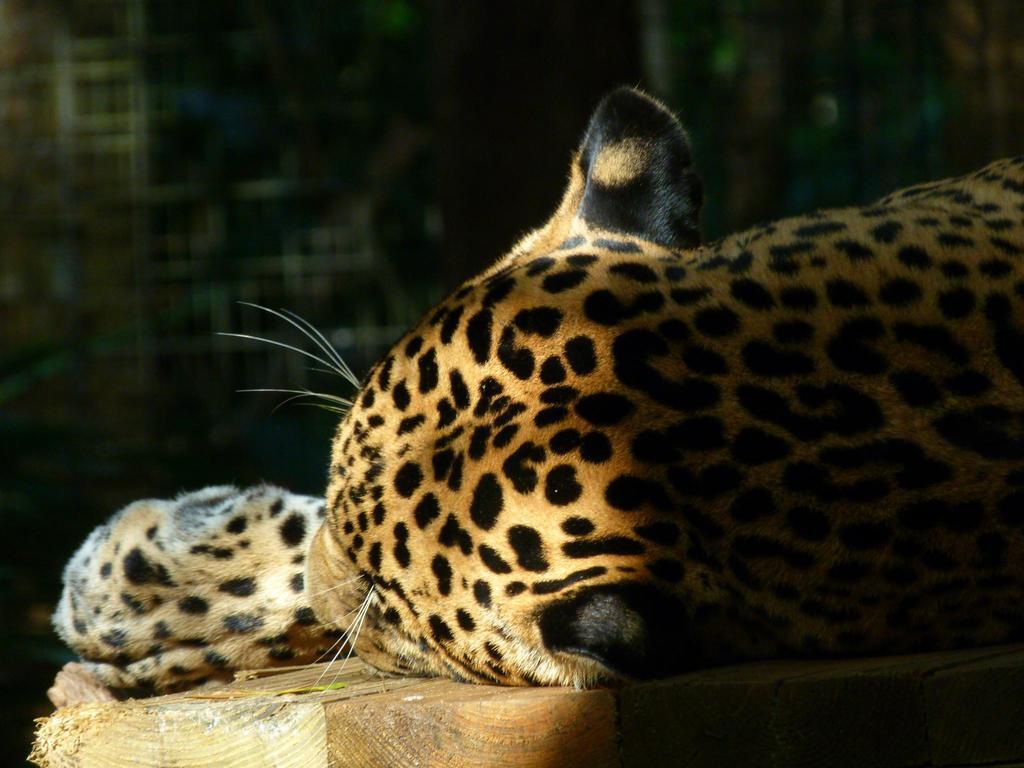In one or two sentences, can you explain what this image depicts? In this image I can see a cheetah which is orange, black and white in color is laying on the wooden surface which is brown in color. I can see the dark background. 